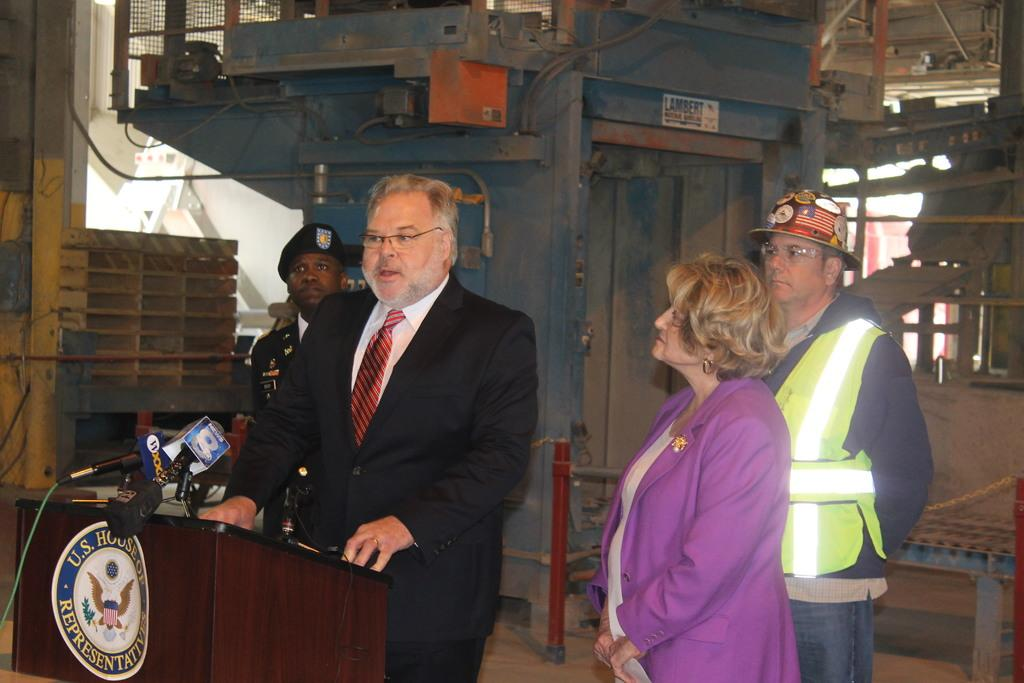What is located at the bottom of the image? There is a podium at the bottom of the image. What can be found on the podium? There are microphones on the podium. Who is standing near the podium? There are people standing behind the podium. What can be seen in the background of the image? There are machines visible in the background of the image. Can you see a glove on the face of the person standing behind the podium? There is no glove visible on the face of the person standing behind the podium in the image. 